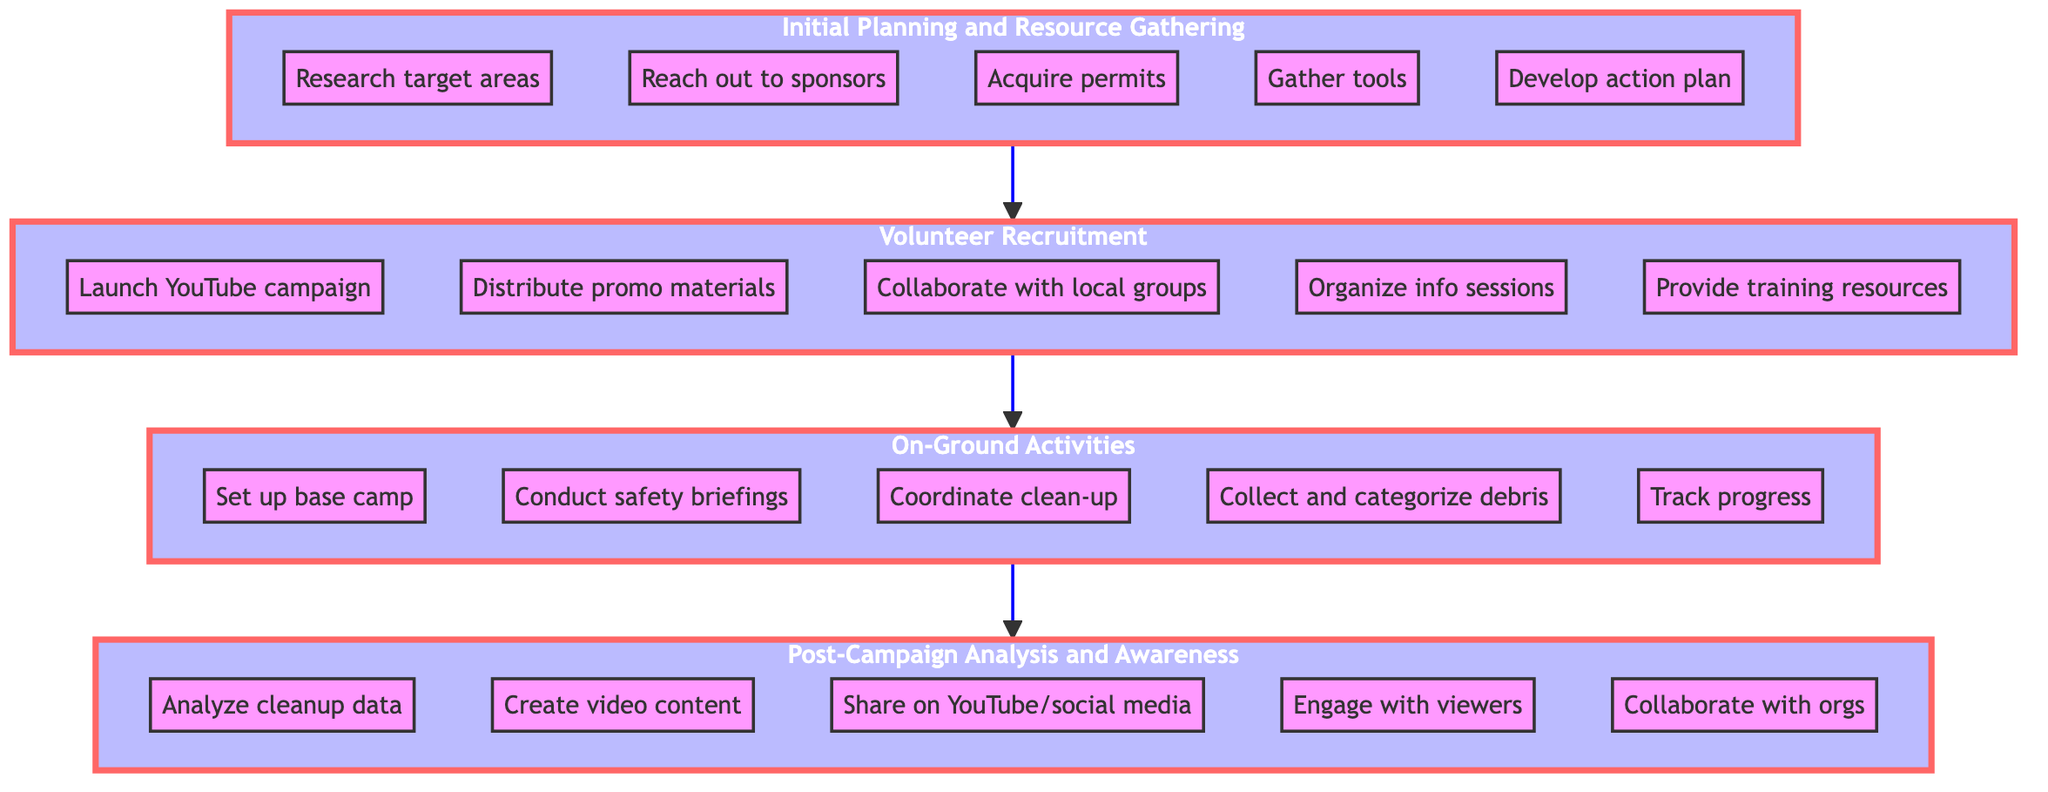What is the top stage in the flow chart? The top stage is always the last step in the flow of the chart. In this case, it is "Post-Campaign Analysis and Awareness Dissemination" which is positioned at the top of the diagram.
Answer: Post-Campaign Analysis and Awareness Dissemination How many main stages are there in the diagram? By counting the distinct subgraphs or stages in the flow chart, we can identify that there are four main stages: Initial Planning and Resource Gathering, Volunteer Recruitment, On-Ground Activities, and Post-Campaign Analysis and Awareness Dissemination.
Answer: 4 What is the first step in the flow chart? The first step appears at the bottom of the flow chart in the "Initial Planning and Resource Gathering" stage. The bottommost node there is "Research and identify target areas for cleanup", which is the starting action in the entire process.
Answer: Research target areas What action occurs after "Organize info sessions"? To find the next action after “Organize info sessions”, we look for the node that follows the "Volunteer Recruitment" stage, which connects to the first action in the "On-Ground Activities" stage that is "Set up base camp".
Answer: Set up base camp What is the purpose of the "Post-Campaign Analysis and Awareness Dissemination" stage? The purpose of this stage focuses on evaluating the success of the previous actions taken during the campaign, which includes data collection, creating content, and raising awareness about the efforts. This is inferred from the steps listed under this stage.
Answer: Evaluate success Which step involves volunteer engagement? Looking through the "Post-Campaign Analysis and Awareness Dissemination" stage, the step that directly mentions engaging with an audience is "Engage with viewers through live Q&A sessions and comments". This highlights how volunteers can be engaged after the campaign.
Answer: Engage with viewers What step precedes "Collect and categorize debris"? The step that occurs immediately before "Collect and categorize debris" is "Coordinate clean-up activities across designated areas", as these actions are sequential within the "On-Ground Activities" stage.
Answer: Coordinate clean-up activities What is the function of the "Volunteer Recruitment" stage in the overall flow? This stage serves to attract and prepare individuals to participate in the campaign. It is essential to create a team that will actively engage in the cleanup efforts outlined in the following stage.
Answer: Attract and prepare volunteers 